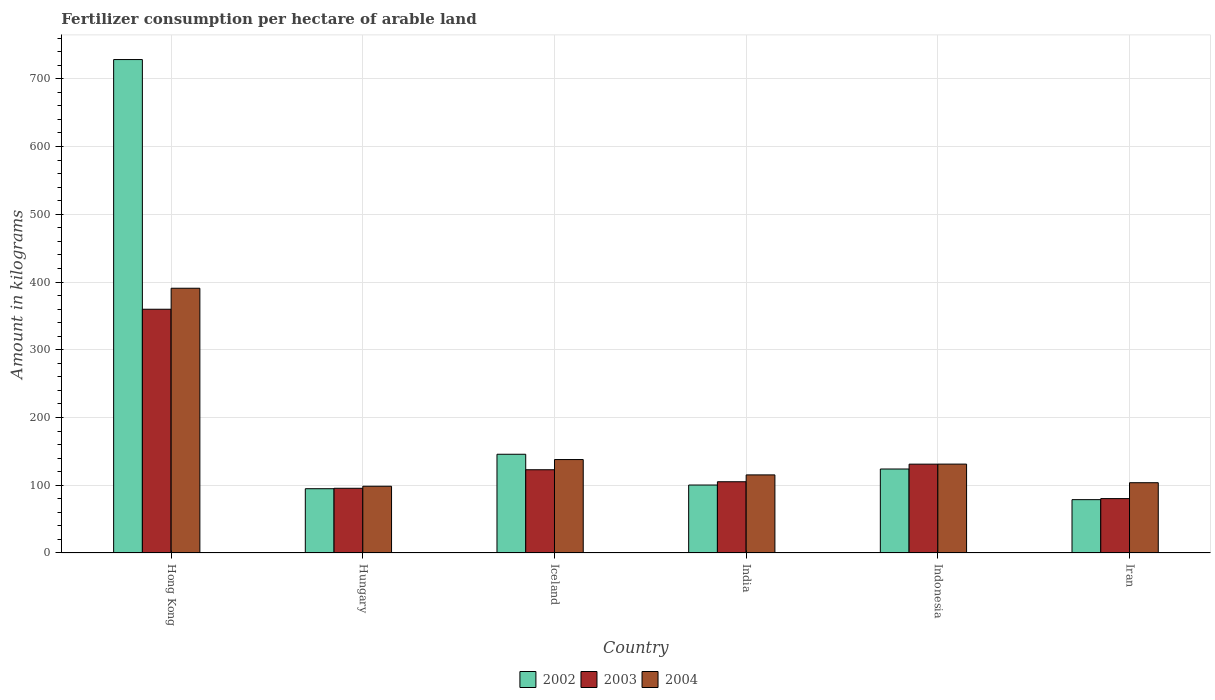How many different coloured bars are there?
Provide a succinct answer. 3. How many groups of bars are there?
Offer a very short reply. 6. Are the number of bars on each tick of the X-axis equal?
Your answer should be very brief. Yes. How many bars are there on the 2nd tick from the right?
Give a very brief answer. 3. What is the label of the 6th group of bars from the left?
Ensure brevity in your answer.  Iran. In how many cases, is the number of bars for a given country not equal to the number of legend labels?
Ensure brevity in your answer.  0. What is the amount of fertilizer consumption in 2002 in Iran?
Make the answer very short. 78.74. Across all countries, what is the maximum amount of fertilizer consumption in 2002?
Give a very brief answer. 728.4. Across all countries, what is the minimum amount of fertilizer consumption in 2002?
Keep it short and to the point. 78.74. In which country was the amount of fertilizer consumption in 2002 maximum?
Provide a succinct answer. Hong Kong. In which country was the amount of fertilizer consumption in 2002 minimum?
Provide a succinct answer. Iran. What is the total amount of fertilizer consumption in 2004 in the graph?
Your answer should be very brief. 977.48. What is the difference between the amount of fertilizer consumption in 2002 in Indonesia and that in Iran?
Offer a very short reply. 45.22. What is the difference between the amount of fertilizer consumption in 2002 in Hong Kong and the amount of fertilizer consumption in 2003 in Iran?
Your response must be concise. 648.11. What is the average amount of fertilizer consumption in 2004 per country?
Ensure brevity in your answer.  162.91. What is the difference between the amount of fertilizer consumption of/in 2003 and amount of fertilizer consumption of/in 2002 in Iran?
Offer a very short reply. 1.55. What is the ratio of the amount of fertilizer consumption in 2004 in Hong Kong to that in Indonesia?
Your answer should be compact. 2.98. Is the amount of fertilizer consumption in 2002 in Hungary less than that in India?
Your response must be concise. Yes. Is the difference between the amount of fertilizer consumption in 2003 in Iceland and India greater than the difference between the amount of fertilizer consumption in 2002 in Iceland and India?
Give a very brief answer. No. What is the difference between the highest and the second highest amount of fertilizer consumption in 2002?
Offer a very short reply. 582.65. What is the difference between the highest and the lowest amount of fertilizer consumption in 2003?
Your answer should be compact. 279.51. In how many countries, is the amount of fertilizer consumption in 2004 greater than the average amount of fertilizer consumption in 2004 taken over all countries?
Ensure brevity in your answer.  1. Is the sum of the amount of fertilizer consumption in 2004 in Hong Kong and India greater than the maximum amount of fertilizer consumption in 2002 across all countries?
Provide a succinct answer. No. What does the 1st bar from the right in Hong Kong represents?
Provide a short and direct response. 2004. Are all the bars in the graph horizontal?
Keep it short and to the point. No. How many countries are there in the graph?
Your answer should be very brief. 6. What is the difference between two consecutive major ticks on the Y-axis?
Give a very brief answer. 100. Does the graph contain grids?
Offer a terse response. Yes. What is the title of the graph?
Your answer should be very brief. Fertilizer consumption per hectare of arable land. What is the label or title of the X-axis?
Keep it short and to the point. Country. What is the label or title of the Y-axis?
Your answer should be compact. Amount in kilograms. What is the Amount in kilograms of 2002 in Hong Kong?
Your answer should be very brief. 728.4. What is the Amount in kilograms in 2003 in Hong Kong?
Your response must be concise. 359.8. What is the Amount in kilograms in 2004 in Hong Kong?
Keep it short and to the point. 390.8. What is the Amount in kilograms of 2002 in Hungary?
Offer a very short reply. 94.88. What is the Amount in kilograms in 2003 in Hungary?
Keep it short and to the point. 95.5. What is the Amount in kilograms in 2004 in Hungary?
Make the answer very short. 98.52. What is the Amount in kilograms of 2002 in Iceland?
Provide a succinct answer. 145.75. What is the Amount in kilograms of 2003 in Iceland?
Your answer should be very brief. 122.88. What is the Amount in kilograms in 2004 in Iceland?
Your answer should be very brief. 137.92. What is the Amount in kilograms in 2002 in India?
Keep it short and to the point. 100.33. What is the Amount in kilograms in 2003 in India?
Ensure brevity in your answer.  105.18. What is the Amount in kilograms of 2004 in India?
Give a very brief answer. 115.27. What is the Amount in kilograms in 2002 in Indonesia?
Provide a short and direct response. 123.96. What is the Amount in kilograms in 2003 in Indonesia?
Keep it short and to the point. 131.13. What is the Amount in kilograms in 2004 in Indonesia?
Offer a very short reply. 131.21. What is the Amount in kilograms of 2002 in Iran?
Your answer should be compact. 78.74. What is the Amount in kilograms of 2003 in Iran?
Offer a very short reply. 80.29. What is the Amount in kilograms in 2004 in Iran?
Your answer should be very brief. 103.75. Across all countries, what is the maximum Amount in kilograms in 2002?
Keep it short and to the point. 728.4. Across all countries, what is the maximum Amount in kilograms in 2003?
Ensure brevity in your answer.  359.8. Across all countries, what is the maximum Amount in kilograms in 2004?
Provide a short and direct response. 390.8. Across all countries, what is the minimum Amount in kilograms in 2002?
Provide a succinct answer. 78.74. Across all countries, what is the minimum Amount in kilograms of 2003?
Keep it short and to the point. 80.29. Across all countries, what is the minimum Amount in kilograms in 2004?
Offer a terse response. 98.52. What is the total Amount in kilograms of 2002 in the graph?
Give a very brief answer. 1272.06. What is the total Amount in kilograms in 2003 in the graph?
Give a very brief answer. 894.78. What is the total Amount in kilograms of 2004 in the graph?
Make the answer very short. 977.48. What is the difference between the Amount in kilograms in 2002 in Hong Kong and that in Hungary?
Keep it short and to the point. 633.52. What is the difference between the Amount in kilograms in 2003 in Hong Kong and that in Hungary?
Your answer should be compact. 264.3. What is the difference between the Amount in kilograms of 2004 in Hong Kong and that in Hungary?
Provide a succinct answer. 292.28. What is the difference between the Amount in kilograms of 2002 in Hong Kong and that in Iceland?
Make the answer very short. 582.65. What is the difference between the Amount in kilograms in 2003 in Hong Kong and that in Iceland?
Offer a very short reply. 236.92. What is the difference between the Amount in kilograms in 2004 in Hong Kong and that in Iceland?
Offer a very short reply. 252.88. What is the difference between the Amount in kilograms of 2002 in Hong Kong and that in India?
Make the answer very short. 628.07. What is the difference between the Amount in kilograms of 2003 in Hong Kong and that in India?
Ensure brevity in your answer.  254.62. What is the difference between the Amount in kilograms in 2004 in Hong Kong and that in India?
Offer a terse response. 275.53. What is the difference between the Amount in kilograms of 2002 in Hong Kong and that in Indonesia?
Your answer should be compact. 604.44. What is the difference between the Amount in kilograms of 2003 in Hong Kong and that in Indonesia?
Provide a succinct answer. 228.67. What is the difference between the Amount in kilograms of 2004 in Hong Kong and that in Indonesia?
Keep it short and to the point. 259.59. What is the difference between the Amount in kilograms of 2002 in Hong Kong and that in Iran?
Your answer should be compact. 649.66. What is the difference between the Amount in kilograms in 2003 in Hong Kong and that in Iran?
Keep it short and to the point. 279.51. What is the difference between the Amount in kilograms in 2004 in Hong Kong and that in Iran?
Provide a succinct answer. 287.05. What is the difference between the Amount in kilograms in 2002 in Hungary and that in Iceland?
Give a very brief answer. -50.88. What is the difference between the Amount in kilograms of 2003 in Hungary and that in Iceland?
Your response must be concise. -27.39. What is the difference between the Amount in kilograms in 2004 in Hungary and that in Iceland?
Your answer should be compact. -39.4. What is the difference between the Amount in kilograms of 2002 in Hungary and that in India?
Your response must be concise. -5.45. What is the difference between the Amount in kilograms of 2003 in Hungary and that in India?
Ensure brevity in your answer.  -9.68. What is the difference between the Amount in kilograms of 2004 in Hungary and that in India?
Keep it short and to the point. -16.75. What is the difference between the Amount in kilograms in 2002 in Hungary and that in Indonesia?
Your answer should be very brief. -29.08. What is the difference between the Amount in kilograms in 2003 in Hungary and that in Indonesia?
Ensure brevity in your answer.  -35.64. What is the difference between the Amount in kilograms in 2004 in Hungary and that in Indonesia?
Offer a terse response. -32.69. What is the difference between the Amount in kilograms of 2002 in Hungary and that in Iran?
Provide a short and direct response. 16.14. What is the difference between the Amount in kilograms of 2003 in Hungary and that in Iran?
Your answer should be compact. 15.21. What is the difference between the Amount in kilograms of 2004 in Hungary and that in Iran?
Give a very brief answer. -5.23. What is the difference between the Amount in kilograms in 2002 in Iceland and that in India?
Make the answer very short. 45.42. What is the difference between the Amount in kilograms of 2003 in Iceland and that in India?
Ensure brevity in your answer.  17.71. What is the difference between the Amount in kilograms of 2004 in Iceland and that in India?
Give a very brief answer. 22.65. What is the difference between the Amount in kilograms of 2002 in Iceland and that in Indonesia?
Offer a terse response. 21.79. What is the difference between the Amount in kilograms of 2003 in Iceland and that in Indonesia?
Keep it short and to the point. -8.25. What is the difference between the Amount in kilograms in 2004 in Iceland and that in Indonesia?
Keep it short and to the point. 6.71. What is the difference between the Amount in kilograms in 2002 in Iceland and that in Iran?
Your response must be concise. 67.01. What is the difference between the Amount in kilograms in 2003 in Iceland and that in Iran?
Offer a terse response. 42.59. What is the difference between the Amount in kilograms of 2004 in Iceland and that in Iran?
Give a very brief answer. 34.17. What is the difference between the Amount in kilograms of 2002 in India and that in Indonesia?
Make the answer very short. -23.63. What is the difference between the Amount in kilograms of 2003 in India and that in Indonesia?
Offer a very short reply. -25.95. What is the difference between the Amount in kilograms in 2004 in India and that in Indonesia?
Ensure brevity in your answer.  -15.94. What is the difference between the Amount in kilograms of 2002 in India and that in Iran?
Make the answer very short. 21.59. What is the difference between the Amount in kilograms of 2003 in India and that in Iran?
Ensure brevity in your answer.  24.89. What is the difference between the Amount in kilograms in 2004 in India and that in Iran?
Offer a terse response. 11.52. What is the difference between the Amount in kilograms in 2002 in Indonesia and that in Iran?
Give a very brief answer. 45.22. What is the difference between the Amount in kilograms of 2003 in Indonesia and that in Iran?
Your response must be concise. 50.84. What is the difference between the Amount in kilograms in 2004 in Indonesia and that in Iran?
Ensure brevity in your answer.  27.46. What is the difference between the Amount in kilograms of 2002 in Hong Kong and the Amount in kilograms of 2003 in Hungary?
Your answer should be very brief. 632.9. What is the difference between the Amount in kilograms of 2002 in Hong Kong and the Amount in kilograms of 2004 in Hungary?
Your response must be concise. 629.88. What is the difference between the Amount in kilograms of 2003 in Hong Kong and the Amount in kilograms of 2004 in Hungary?
Make the answer very short. 261.28. What is the difference between the Amount in kilograms in 2002 in Hong Kong and the Amount in kilograms in 2003 in Iceland?
Offer a terse response. 605.52. What is the difference between the Amount in kilograms in 2002 in Hong Kong and the Amount in kilograms in 2004 in Iceland?
Give a very brief answer. 590.48. What is the difference between the Amount in kilograms of 2003 in Hong Kong and the Amount in kilograms of 2004 in Iceland?
Keep it short and to the point. 221.88. What is the difference between the Amount in kilograms in 2002 in Hong Kong and the Amount in kilograms in 2003 in India?
Your answer should be very brief. 623.22. What is the difference between the Amount in kilograms in 2002 in Hong Kong and the Amount in kilograms in 2004 in India?
Ensure brevity in your answer.  613.13. What is the difference between the Amount in kilograms of 2003 in Hong Kong and the Amount in kilograms of 2004 in India?
Your response must be concise. 244.53. What is the difference between the Amount in kilograms in 2002 in Hong Kong and the Amount in kilograms in 2003 in Indonesia?
Give a very brief answer. 597.27. What is the difference between the Amount in kilograms in 2002 in Hong Kong and the Amount in kilograms in 2004 in Indonesia?
Your response must be concise. 597.19. What is the difference between the Amount in kilograms in 2003 in Hong Kong and the Amount in kilograms in 2004 in Indonesia?
Make the answer very short. 228.59. What is the difference between the Amount in kilograms in 2002 in Hong Kong and the Amount in kilograms in 2003 in Iran?
Keep it short and to the point. 648.11. What is the difference between the Amount in kilograms of 2002 in Hong Kong and the Amount in kilograms of 2004 in Iran?
Provide a succinct answer. 624.65. What is the difference between the Amount in kilograms of 2003 in Hong Kong and the Amount in kilograms of 2004 in Iran?
Offer a very short reply. 256.05. What is the difference between the Amount in kilograms of 2002 in Hungary and the Amount in kilograms of 2003 in Iceland?
Your response must be concise. -28.01. What is the difference between the Amount in kilograms of 2002 in Hungary and the Amount in kilograms of 2004 in Iceland?
Keep it short and to the point. -43.05. What is the difference between the Amount in kilograms in 2003 in Hungary and the Amount in kilograms in 2004 in Iceland?
Give a very brief answer. -42.43. What is the difference between the Amount in kilograms of 2002 in Hungary and the Amount in kilograms of 2003 in India?
Provide a short and direct response. -10.3. What is the difference between the Amount in kilograms of 2002 in Hungary and the Amount in kilograms of 2004 in India?
Give a very brief answer. -20.4. What is the difference between the Amount in kilograms of 2003 in Hungary and the Amount in kilograms of 2004 in India?
Provide a short and direct response. -19.77. What is the difference between the Amount in kilograms of 2002 in Hungary and the Amount in kilograms of 2003 in Indonesia?
Provide a succinct answer. -36.26. What is the difference between the Amount in kilograms of 2002 in Hungary and the Amount in kilograms of 2004 in Indonesia?
Provide a succinct answer. -36.33. What is the difference between the Amount in kilograms of 2003 in Hungary and the Amount in kilograms of 2004 in Indonesia?
Keep it short and to the point. -35.71. What is the difference between the Amount in kilograms of 2002 in Hungary and the Amount in kilograms of 2003 in Iran?
Make the answer very short. 14.58. What is the difference between the Amount in kilograms in 2002 in Hungary and the Amount in kilograms in 2004 in Iran?
Provide a short and direct response. -8.88. What is the difference between the Amount in kilograms in 2003 in Hungary and the Amount in kilograms in 2004 in Iran?
Offer a very short reply. -8.25. What is the difference between the Amount in kilograms of 2002 in Iceland and the Amount in kilograms of 2003 in India?
Your response must be concise. 40.57. What is the difference between the Amount in kilograms in 2002 in Iceland and the Amount in kilograms in 2004 in India?
Provide a succinct answer. 30.48. What is the difference between the Amount in kilograms in 2003 in Iceland and the Amount in kilograms in 2004 in India?
Provide a succinct answer. 7.61. What is the difference between the Amount in kilograms of 2002 in Iceland and the Amount in kilograms of 2003 in Indonesia?
Your answer should be compact. 14.62. What is the difference between the Amount in kilograms of 2002 in Iceland and the Amount in kilograms of 2004 in Indonesia?
Give a very brief answer. 14.54. What is the difference between the Amount in kilograms of 2003 in Iceland and the Amount in kilograms of 2004 in Indonesia?
Provide a succinct answer. -8.33. What is the difference between the Amount in kilograms in 2002 in Iceland and the Amount in kilograms in 2003 in Iran?
Provide a short and direct response. 65.46. What is the difference between the Amount in kilograms in 2002 in Iceland and the Amount in kilograms in 2004 in Iran?
Your answer should be very brief. 42. What is the difference between the Amount in kilograms in 2003 in Iceland and the Amount in kilograms in 2004 in Iran?
Make the answer very short. 19.13. What is the difference between the Amount in kilograms of 2002 in India and the Amount in kilograms of 2003 in Indonesia?
Your answer should be very brief. -30.8. What is the difference between the Amount in kilograms of 2002 in India and the Amount in kilograms of 2004 in Indonesia?
Offer a very short reply. -30.88. What is the difference between the Amount in kilograms of 2003 in India and the Amount in kilograms of 2004 in Indonesia?
Provide a succinct answer. -26.03. What is the difference between the Amount in kilograms in 2002 in India and the Amount in kilograms in 2003 in Iran?
Provide a succinct answer. 20.04. What is the difference between the Amount in kilograms in 2002 in India and the Amount in kilograms in 2004 in Iran?
Provide a succinct answer. -3.42. What is the difference between the Amount in kilograms in 2003 in India and the Amount in kilograms in 2004 in Iran?
Your response must be concise. 1.43. What is the difference between the Amount in kilograms in 2002 in Indonesia and the Amount in kilograms in 2003 in Iran?
Provide a short and direct response. 43.67. What is the difference between the Amount in kilograms in 2002 in Indonesia and the Amount in kilograms in 2004 in Iran?
Provide a succinct answer. 20.21. What is the difference between the Amount in kilograms of 2003 in Indonesia and the Amount in kilograms of 2004 in Iran?
Your answer should be very brief. 27.38. What is the average Amount in kilograms in 2002 per country?
Your answer should be compact. 212.01. What is the average Amount in kilograms in 2003 per country?
Provide a succinct answer. 149.13. What is the average Amount in kilograms in 2004 per country?
Ensure brevity in your answer.  162.91. What is the difference between the Amount in kilograms of 2002 and Amount in kilograms of 2003 in Hong Kong?
Offer a terse response. 368.6. What is the difference between the Amount in kilograms in 2002 and Amount in kilograms in 2004 in Hong Kong?
Your response must be concise. 337.6. What is the difference between the Amount in kilograms of 2003 and Amount in kilograms of 2004 in Hong Kong?
Offer a very short reply. -31. What is the difference between the Amount in kilograms in 2002 and Amount in kilograms in 2003 in Hungary?
Offer a terse response. -0.62. What is the difference between the Amount in kilograms in 2002 and Amount in kilograms in 2004 in Hungary?
Your answer should be very brief. -3.64. What is the difference between the Amount in kilograms of 2003 and Amount in kilograms of 2004 in Hungary?
Offer a terse response. -3.02. What is the difference between the Amount in kilograms of 2002 and Amount in kilograms of 2003 in Iceland?
Provide a succinct answer. 22.87. What is the difference between the Amount in kilograms in 2002 and Amount in kilograms in 2004 in Iceland?
Provide a succinct answer. 7.83. What is the difference between the Amount in kilograms of 2003 and Amount in kilograms of 2004 in Iceland?
Provide a short and direct response. -15.04. What is the difference between the Amount in kilograms in 2002 and Amount in kilograms in 2003 in India?
Your response must be concise. -4.85. What is the difference between the Amount in kilograms in 2002 and Amount in kilograms in 2004 in India?
Your answer should be very brief. -14.94. What is the difference between the Amount in kilograms of 2003 and Amount in kilograms of 2004 in India?
Your response must be concise. -10.09. What is the difference between the Amount in kilograms in 2002 and Amount in kilograms in 2003 in Indonesia?
Make the answer very short. -7.17. What is the difference between the Amount in kilograms in 2002 and Amount in kilograms in 2004 in Indonesia?
Offer a very short reply. -7.25. What is the difference between the Amount in kilograms of 2003 and Amount in kilograms of 2004 in Indonesia?
Your answer should be very brief. -0.08. What is the difference between the Amount in kilograms in 2002 and Amount in kilograms in 2003 in Iran?
Ensure brevity in your answer.  -1.55. What is the difference between the Amount in kilograms of 2002 and Amount in kilograms of 2004 in Iran?
Your response must be concise. -25.01. What is the difference between the Amount in kilograms of 2003 and Amount in kilograms of 2004 in Iran?
Provide a succinct answer. -23.46. What is the ratio of the Amount in kilograms of 2002 in Hong Kong to that in Hungary?
Provide a succinct answer. 7.68. What is the ratio of the Amount in kilograms of 2003 in Hong Kong to that in Hungary?
Your answer should be very brief. 3.77. What is the ratio of the Amount in kilograms of 2004 in Hong Kong to that in Hungary?
Provide a short and direct response. 3.97. What is the ratio of the Amount in kilograms of 2002 in Hong Kong to that in Iceland?
Provide a short and direct response. 5. What is the ratio of the Amount in kilograms of 2003 in Hong Kong to that in Iceland?
Offer a terse response. 2.93. What is the ratio of the Amount in kilograms in 2004 in Hong Kong to that in Iceland?
Provide a short and direct response. 2.83. What is the ratio of the Amount in kilograms of 2002 in Hong Kong to that in India?
Keep it short and to the point. 7.26. What is the ratio of the Amount in kilograms of 2003 in Hong Kong to that in India?
Ensure brevity in your answer.  3.42. What is the ratio of the Amount in kilograms in 2004 in Hong Kong to that in India?
Keep it short and to the point. 3.39. What is the ratio of the Amount in kilograms in 2002 in Hong Kong to that in Indonesia?
Provide a succinct answer. 5.88. What is the ratio of the Amount in kilograms of 2003 in Hong Kong to that in Indonesia?
Provide a short and direct response. 2.74. What is the ratio of the Amount in kilograms of 2004 in Hong Kong to that in Indonesia?
Your response must be concise. 2.98. What is the ratio of the Amount in kilograms in 2002 in Hong Kong to that in Iran?
Your response must be concise. 9.25. What is the ratio of the Amount in kilograms in 2003 in Hong Kong to that in Iran?
Offer a terse response. 4.48. What is the ratio of the Amount in kilograms in 2004 in Hong Kong to that in Iran?
Your answer should be very brief. 3.77. What is the ratio of the Amount in kilograms of 2002 in Hungary to that in Iceland?
Give a very brief answer. 0.65. What is the ratio of the Amount in kilograms in 2003 in Hungary to that in Iceland?
Give a very brief answer. 0.78. What is the ratio of the Amount in kilograms in 2004 in Hungary to that in Iceland?
Your answer should be compact. 0.71. What is the ratio of the Amount in kilograms of 2002 in Hungary to that in India?
Offer a terse response. 0.95. What is the ratio of the Amount in kilograms of 2003 in Hungary to that in India?
Give a very brief answer. 0.91. What is the ratio of the Amount in kilograms of 2004 in Hungary to that in India?
Ensure brevity in your answer.  0.85. What is the ratio of the Amount in kilograms in 2002 in Hungary to that in Indonesia?
Your answer should be compact. 0.77. What is the ratio of the Amount in kilograms in 2003 in Hungary to that in Indonesia?
Make the answer very short. 0.73. What is the ratio of the Amount in kilograms in 2004 in Hungary to that in Indonesia?
Offer a terse response. 0.75. What is the ratio of the Amount in kilograms in 2002 in Hungary to that in Iran?
Keep it short and to the point. 1.2. What is the ratio of the Amount in kilograms in 2003 in Hungary to that in Iran?
Make the answer very short. 1.19. What is the ratio of the Amount in kilograms of 2004 in Hungary to that in Iran?
Your response must be concise. 0.95. What is the ratio of the Amount in kilograms of 2002 in Iceland to that in India?
Provide a short and direct response. 1.45. What is the ratio of the Amount in kilograms in 2003 in Iceland to that in India?
Provide a short and direct response. 1.17. What is the ratio of the Amount in kilograms of 2004 in Iceland to that in India?
Your answer should be very brief. 1.2. What is the ratio of the Amount in kilograms in 2002 in Iceland to that in Indonesia?
Offer a very short reply. 1.18. What is the ratio of the Amount in kilograms in 2003 in Iceland to that in Indonesia?
Provide a short and direct response. 0.94. What is the ratio of the Amount in kilograms of 2004 in Iceland to that in Indonesia?
Keep it short and to the point. 1.05. What is the ratio of the Amount in kilograms in 2002 in Iceland to that in Iran?
Provide a short and direct response. 1.85. What is the ratio of the Amount in kilograms of 2003 in Iceland to that in Iran?
Offer a terse response. 1.53. What is the ratio of the Amount in kilograms in 2004 in Iceland to that in Iran?
Your answer should be compact. 1.33. What is the ratio of the Amount in kilograms in 2002 in India to that in Indonesia?
Your response must be concise. 0.81. What is the ratio of the Amount in kilograms in 2003 in India to that in Indonesia?
Your answer should be compact. 0.8. What is the ratio of the Amount in kilograms in 2004 in India to that in Indonesia?
Give a very brief answer. 0.88. What is the ratio of the Amount in kilograms in 2002 in India to that in Iran?
Ensure brevity in your answer.  1.27. What is the ratio of the Amount in kilograms of 2003 in India to that in Iran?
Provide a short and direct response. 1.31. What is the ratio of the Amount in kilograms in 2004 in India to that in Iran?
Make the answer very short. 1.11. What is the ratio of the Amount in kilograms in 2002 in Indonesia to that in Iran?
Your response must be concise. 1.57. What is the ratio of the Amount in kilograms in 2003 in Indonesia to that in Iran?
Keep it short and to the point. 1.63. What is the ratio of the Amount in kilograms of 2004 in Indonesia to that in Iran?
Your answer should be compact. 1.26. What is the difference between the highest and the second highest Amount in kilograms in 2002?
Provide a succinct answer. 582.65. What is the difference between the highest and the second highest Amount in kilograms of 2003?
Your answer should be very brief. 228.67. What is the difference between the highest and the second highest Amount in kilograms in 2004?
Offer a very short reply. 252.88. What is the difference between the highest and the lowest Amount in kilograms of 2002?
Your response must be concise. 649.66. What is the difference between the highest and the lowest Amount in kilograms in 2003?
Your response must be concise. 279.51. What is the difference between the highest and the lowest Amount in kilograms in 2004?
Provide a succinct answer. 292.28. 